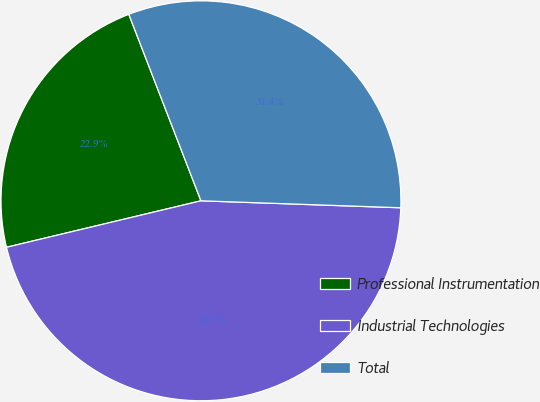Convert chart. <chart><loc_0><loc_0><loc_500><loc_500><pie_chart><fcel>Professional Instrumentation<fcel>Industrial Technologies<fcel>Total<nl><fcel>22.86%<fcel>45.71%<fcel>31.43%<nl></chart> 